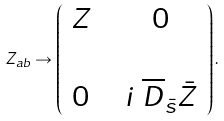<formula> <loc_0><loc_0><loc_500><loc_500>Z _ { a b } \rightarrow \left ( \begin{array} { c c c } Z & & 0 \\ & & \\ 0 & & i \ { \overline { D } } _ { \bar { s } } { \bar { Z } } \end{array} \right ) .</formula> 